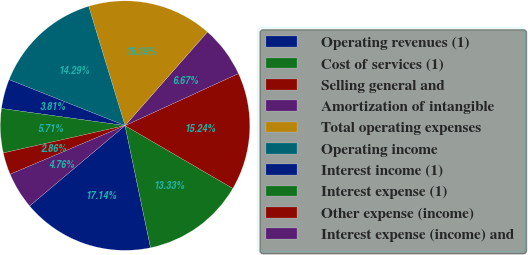Convert chart. <chart><loc_0><loc_0><loc_500><loc_500><pie_chart><fcel>Operating revenues (1)<fcel>Cost of services (1)<fcel>Selling general and<fcel>Amortization of intangible<fcel>Total operating expenses<fcel>Operating income<fcel>Interest income (1)<fcel>Interest expense (1)<fcel>Other expense (income)<fcel>Interest expense (income) and<nl><fcel>17.14%<fcel>13.33%<fcel>15.24%<fcel>6.67%<fcel>16.19%<fcel>14.29%<fcel>3.81%<fcel>5.71%<fcel>2.86%<fcel>4.76%<nl></chart> 